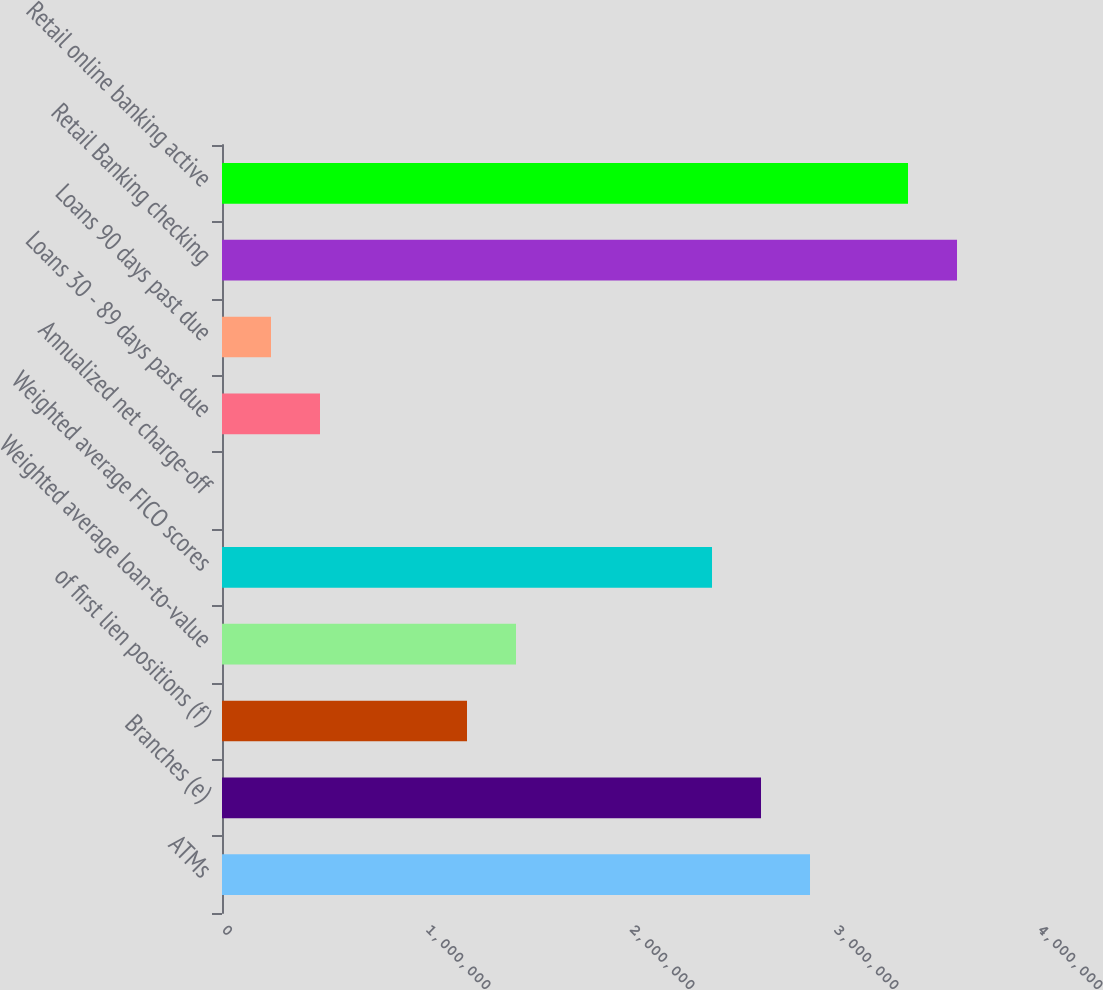Convert chart. <chart><loc_0><loc_0><loc_500><loc_500><bar_chart><fcel>ATMs<fcel>Branches (e)<fcel>of first lien positions (f)<fcel>Weighted average loan-to-value<fcel>Weighted average FICO scores<fcel>Annualized net charge-off<fcel>Loans 30 - 89 days past due<fcel>Loans 90 days past due<fcel>Retail Banking checking<fcel>Retail online banking active<nl><fcel>2.8824e+06<fcel>2.6422e+06<fcel>1.201e+06<fcel>1.4412e+06<fcel>2.402e+06<fcel>0.49<fcel>480400<fcel>240200<fcel>3.603e+06<fcel>3.3628e+06<nl></chart> 